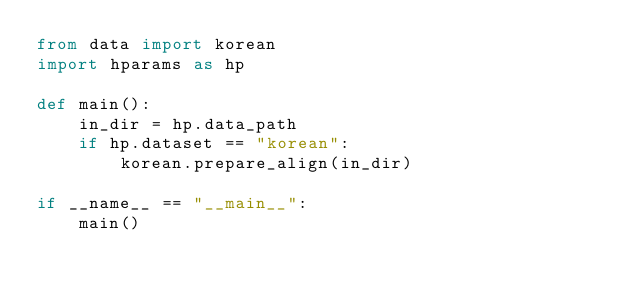Convert code to text. <code><loc_0><loc_0><loc_500><loc_500><_Python_>from data import korean
import hparams as hp

def main():
    in_dir = hp.data_path
    if hp.dataset == "korean":
        korean.prepare_align(in_dir)
    
if __name__ == "__main__":
    main()
</code> 